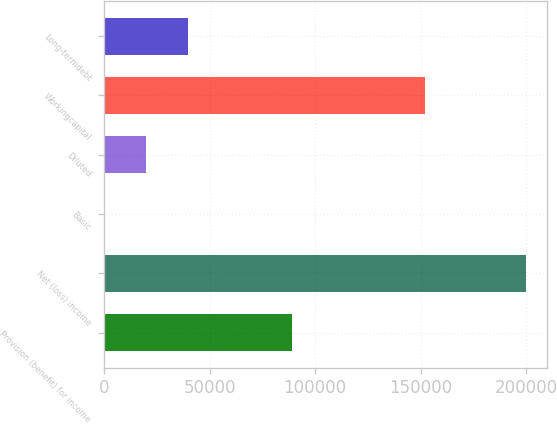Convert chart. <chart><loc_0><loc_0><loc_500><loc_500><bar_chart><fcel>Provision (benefit) for income<fcel>Net (loss) income<fcel>Basic<fcel>Diluted<fcel>Workingcapital<fcel>Long-termdebt<nl><fcel>88947<fcel>199993<fcel>1.5<fcel>20000.7<fcel>151946<fcel>39999.8<nl></chart> 